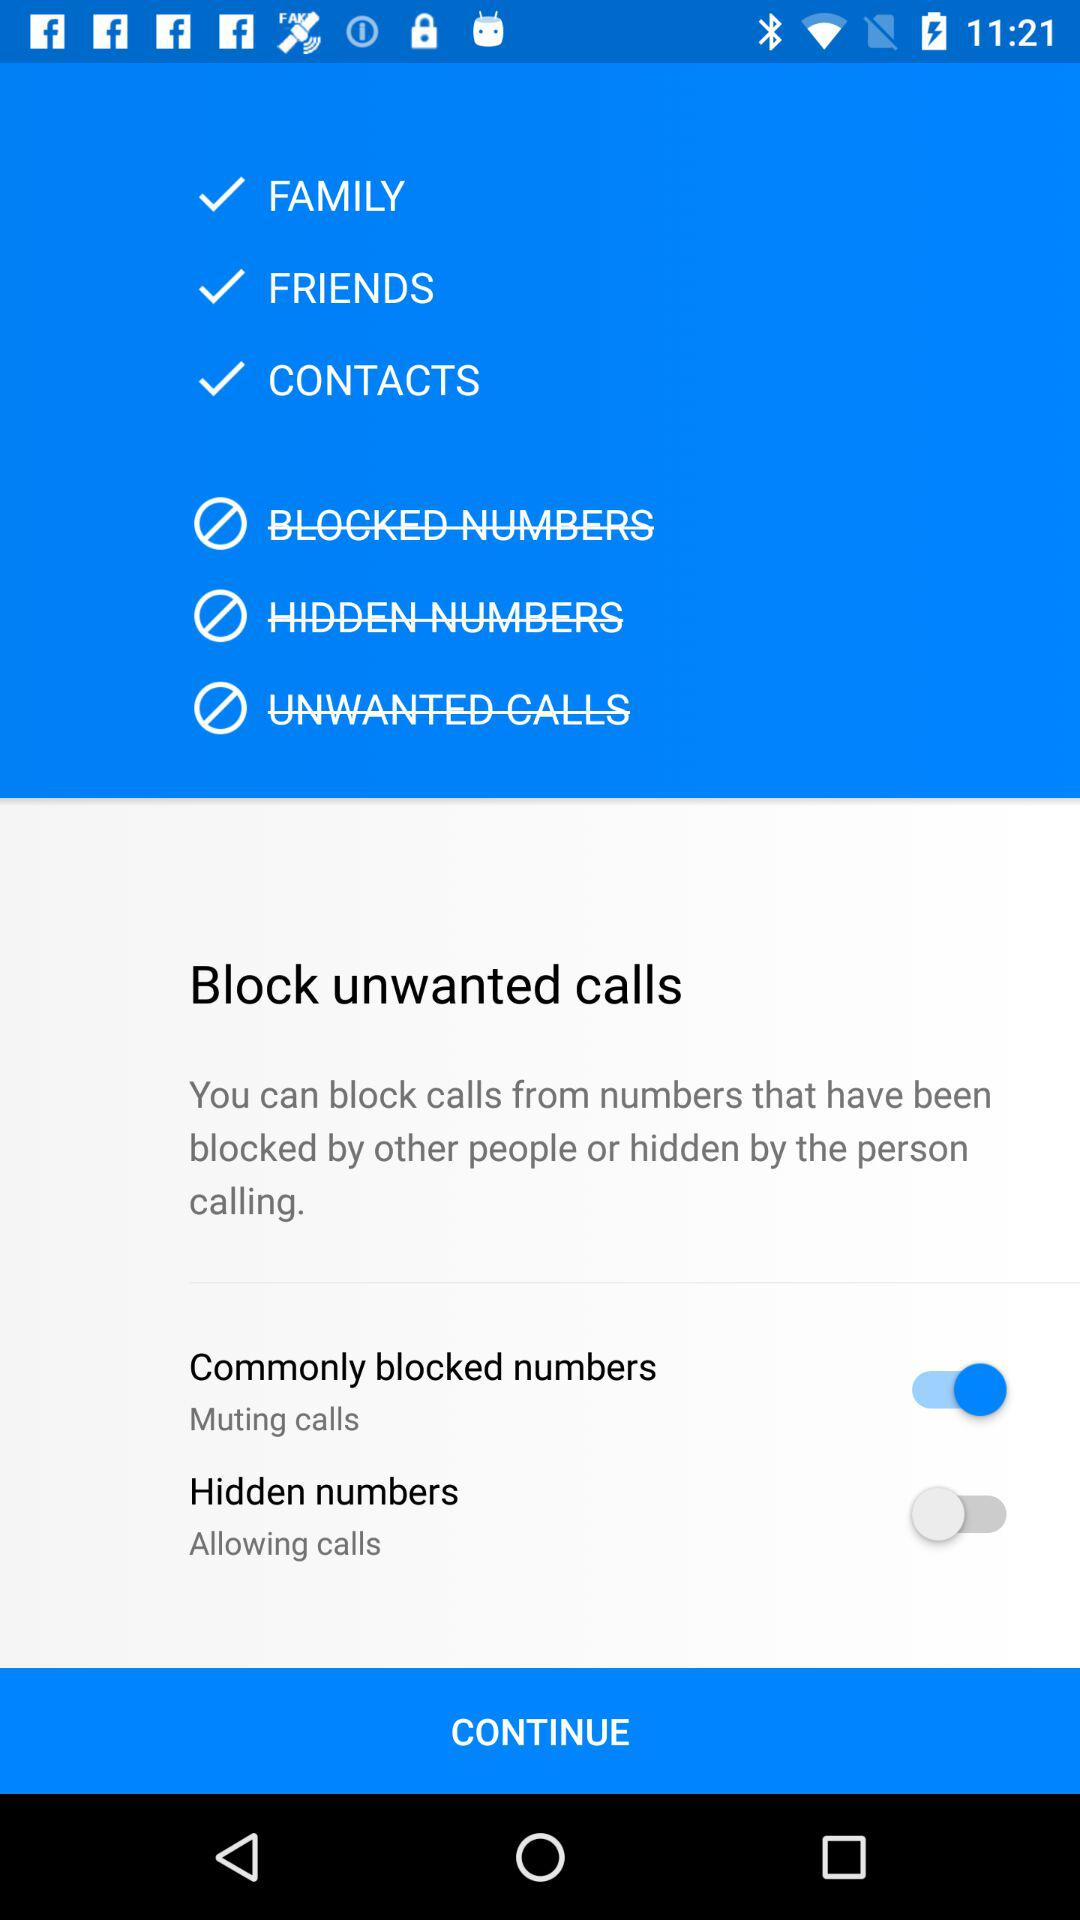What is the status of "Commonly blocked numbers"? The status of "Commonly blocked numbers" is "on". 